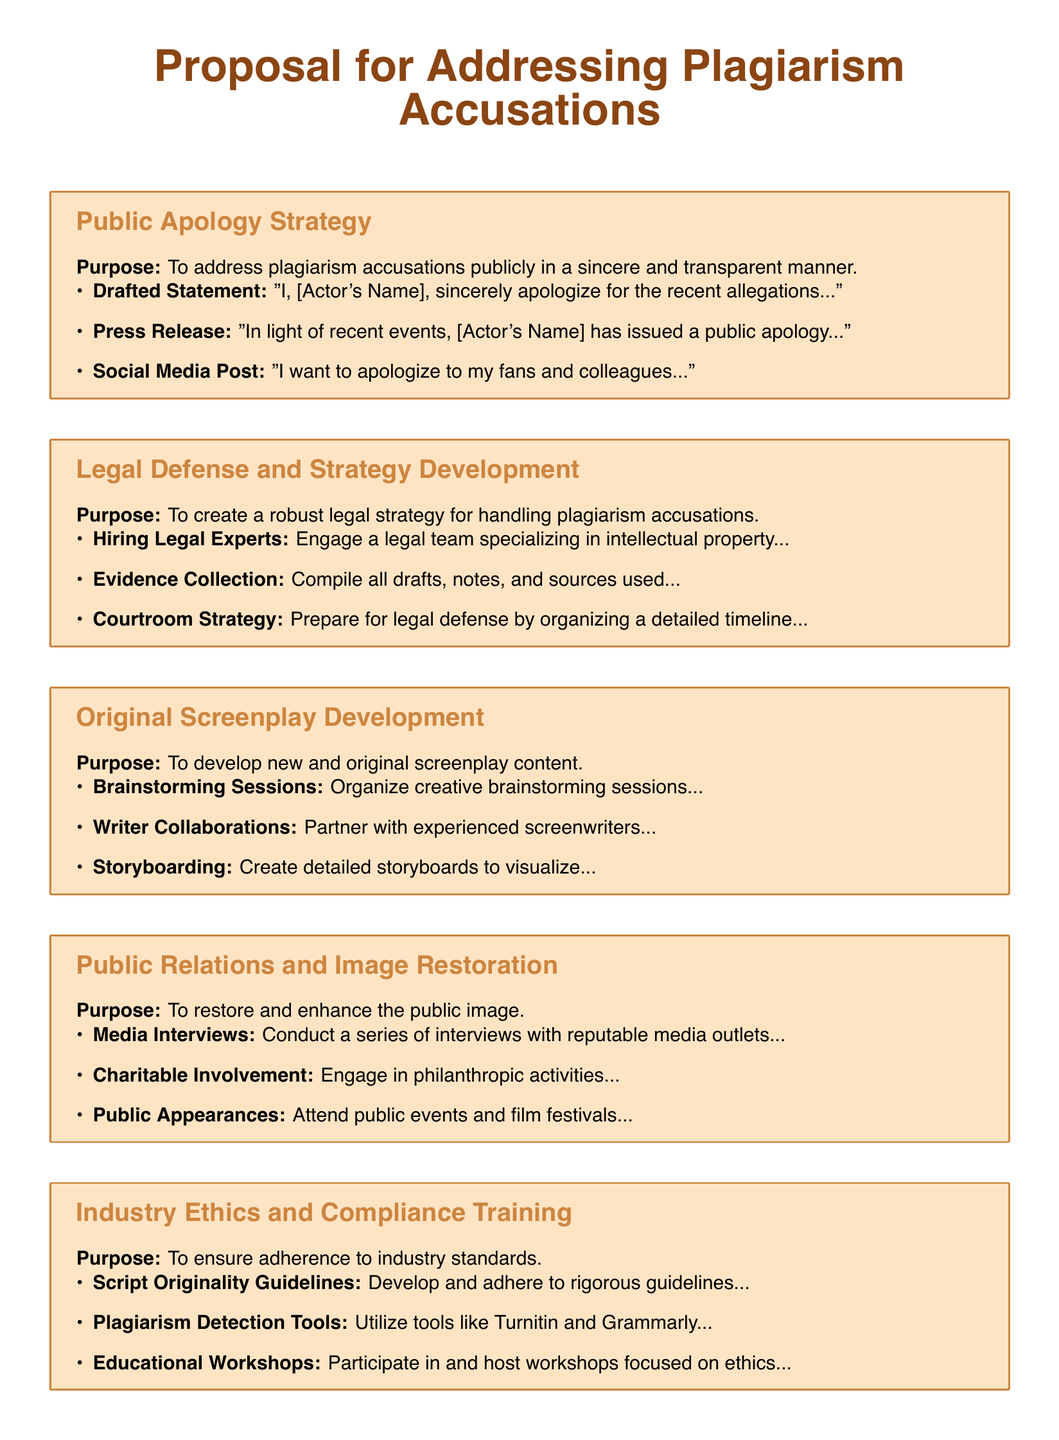What is the primary purpose of the Public Apology Strategy? The primary purpose is to address plagiarism accusations publicly in a sincere and transparent manner.
Answer: To address plagiarism accusations publicly in a sincere and transparent manner Who should be engaged for the Legal Defense and Strategy Development? The document suggests hiring a legal team specializing in intellectual property.
Answer: A legal team specializing in intellectual property What creative process is suggested for Original Screenplay Development? The development process includes organizing creative brainstorming sessions.
Answer: Organizing creative brainstorming sessions What type of involvement is recommended for Public Relations and Image Restoration? Engaging in philanthropic activities is recommended.
Answer: Engaging in philanthropic activities What tools are suggested for ensuring adherence to industry standards? The document suggests utilizing tools like Turnitin and Grammarly.
Answer: Turnitin and Grammarly What is the main focus of the Industry Ethics and Compliance Training? The main focus is to ensure adherence to industry standards.
Answer: To ensure adherence to industry standards What is the drafted public apology statement's opening phrase? The drafted statement begins with "I, [Actor's Name], sincerely apologize..."
Answer: "I, [Actor's Name], sincerely apologize..." How many sections are included in the proposal document? The document contains five sections.
Answer: Five sections What should be prepared as part of the courtroom strategy? A detailed timeline should be organized for the courtroom strategy.
Answer: A detailed timeline How will the public image be enhanced according to the proposal? Conducting a series of interviews with reputable media outlets is part of enhancing the image.
Answer: Conducting media interviews 